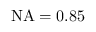Convert formula to latex. <formula><loc_0><loc_0><loc_500><loc_500>N A = 0 . 8 5</formula> 